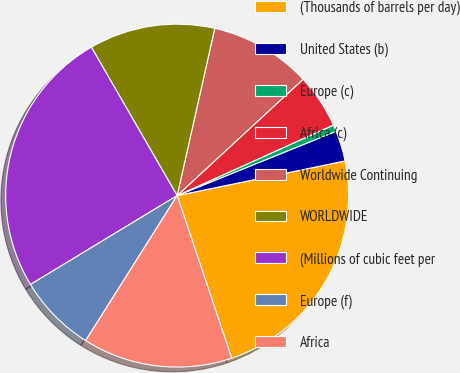Convert chart to OTSL. <chart><loc_0><loc_0><loc_500><loc_500><pie_chart><fcel>(Thousands of barrels per day)<fcel>United States (b)<fcel>Europe (c)<fcel>Africa (c)<fcel>Worldwide Continuing<fcel>WORLDWIDE<fcel>(Millions of cubic feet per<fcel>Europe (f)<fcel>Africa<nl><fcel>23.09%<fcel>2.88%<fcel>0.63%<fcel>5.12%<fcel>9.61%<fcel>11.86%<fcel>25.33%<fcel>7.37%<fcel>14.11%<nl></chart> 